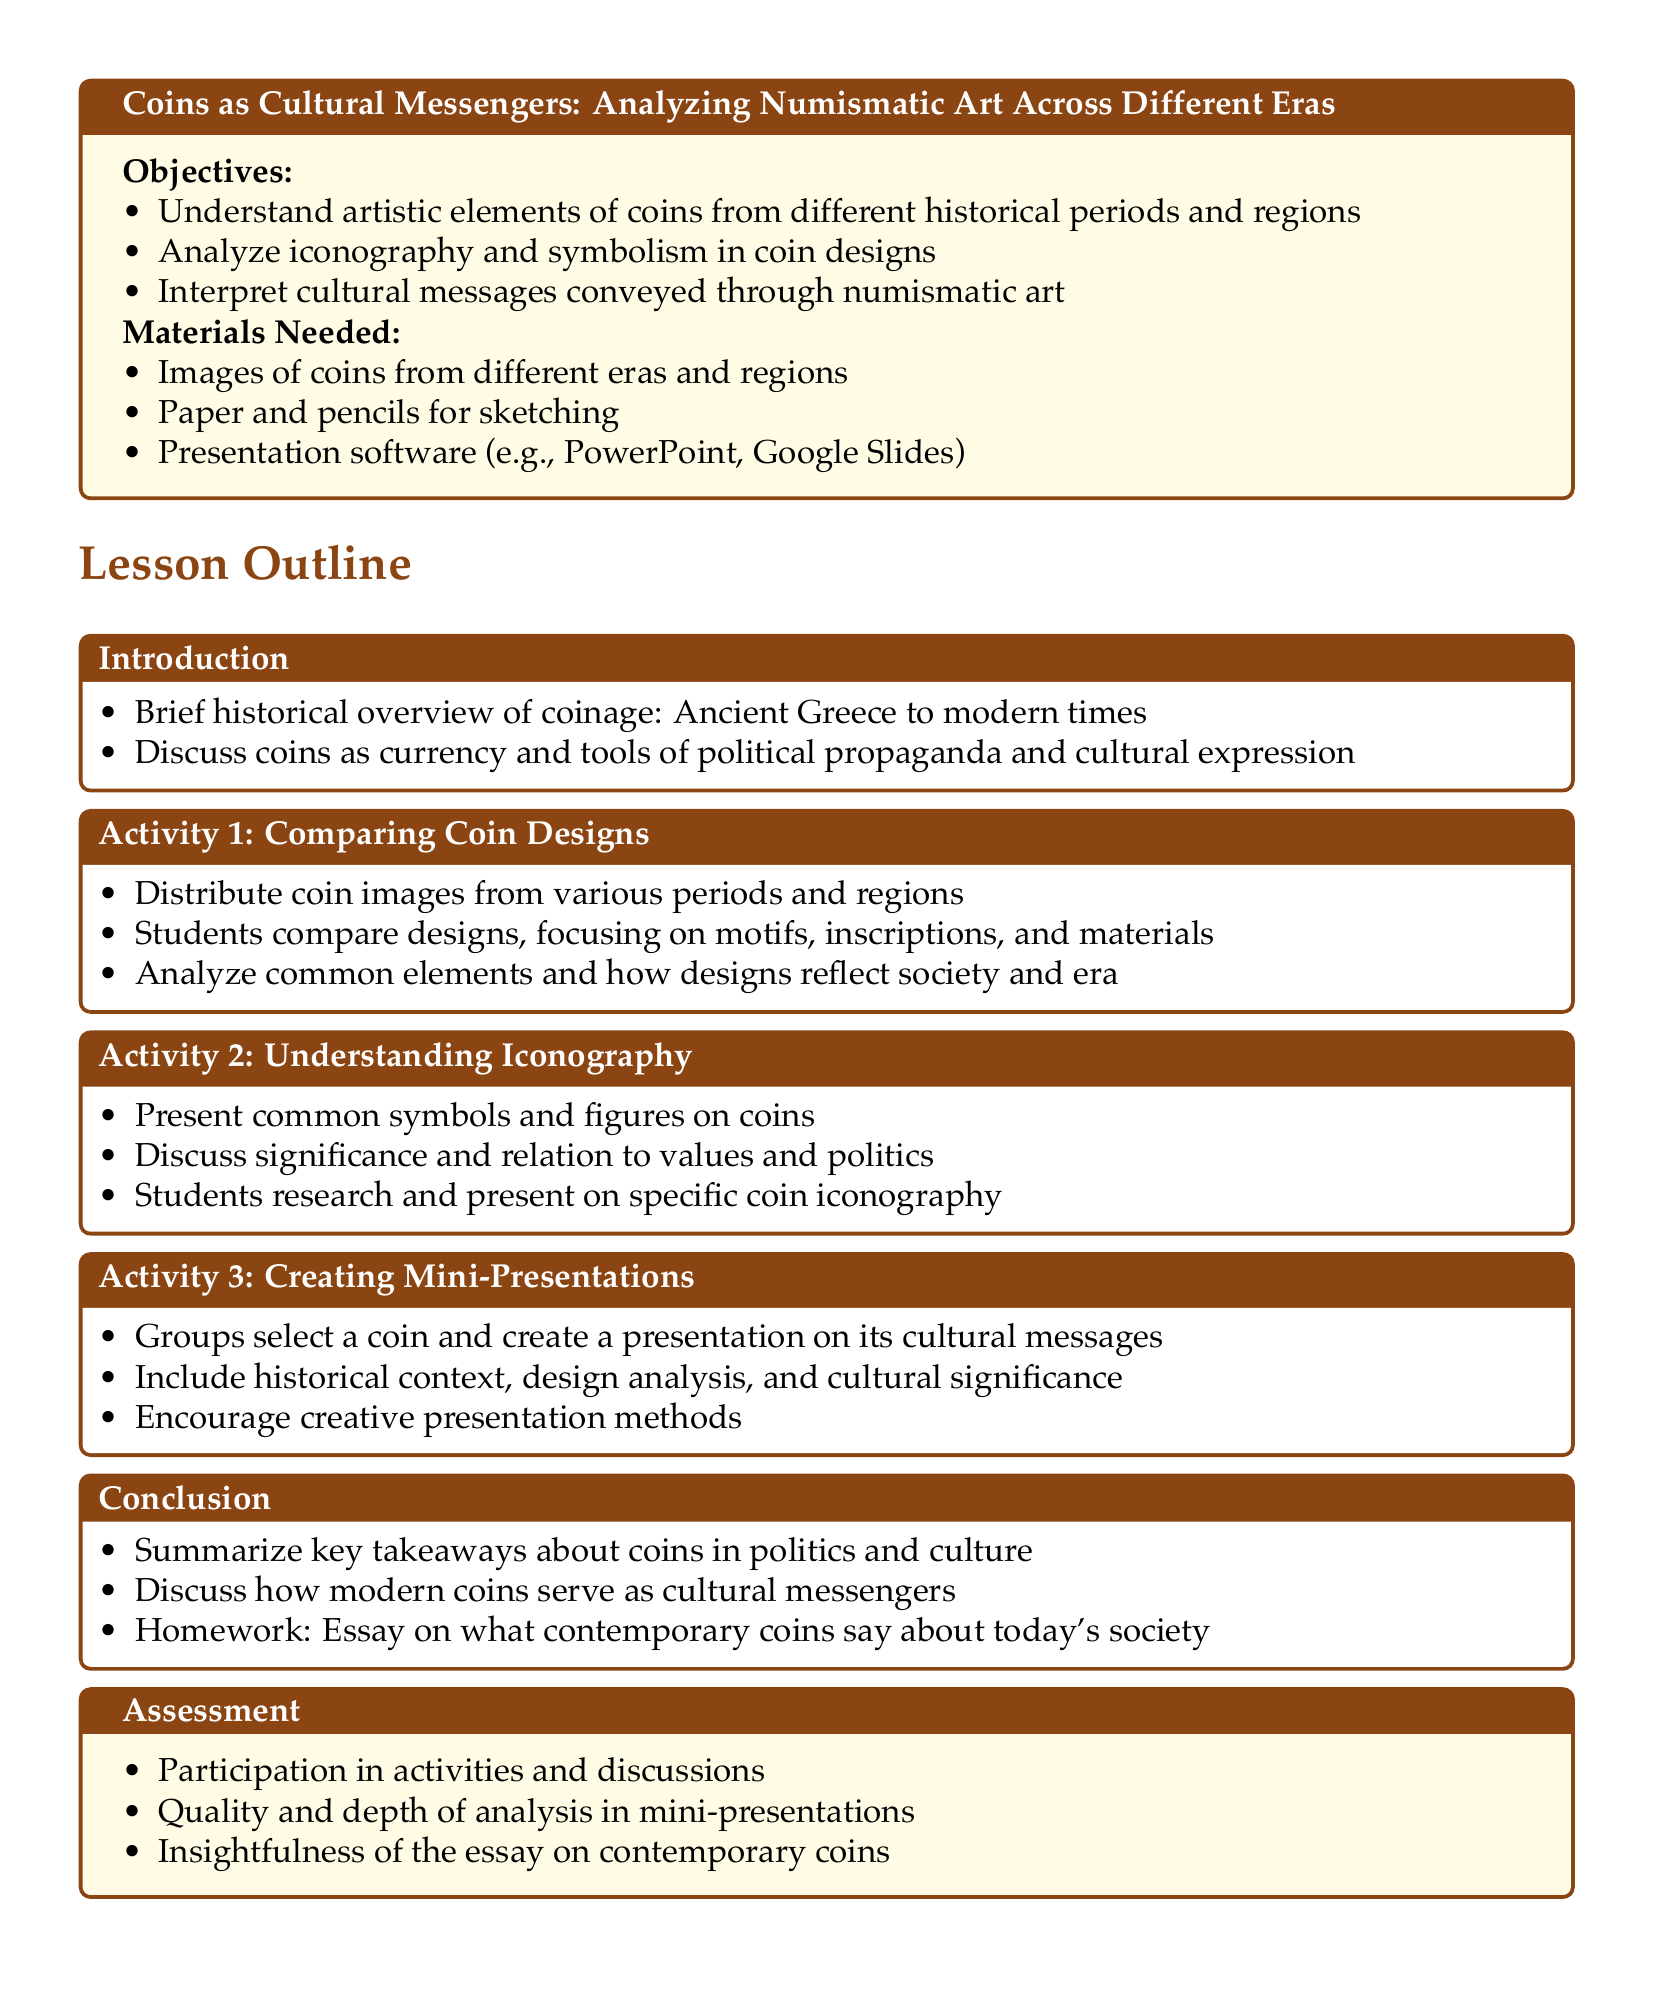What is the title of the lesson plan? The title appears at the top of the document and describes the main subject of the lesson, which deals with coins as cultural messengers.
Answer: Coins as Cultural Messengers: Analyzing Numismatic Art Across Different Eras What is one of the objectives of the lesson plan? Objectives are listed under "Objectives" in the document and highlight what students should understand or achieve.
Answer: Understand artistic elements of coins from different historical periods and regions What is one material needed for the activities? The materials needed are specified in a section of the document and include items necessary for the lesson activities.
Answer: Images of coins from different eras and regions What activity involves comparing designs? Each activity is named in the lesson plan, and this particular activity focuses on comparing coin designs.
Answer: Activity 1: Comparing Coin Designs What is the homework assignment described in the conclusion? The conclusion section summarizes key tasks for students and includes assignments related to the lesson content.
Answer: Essay on what contemporary coins say about today's society What is one type of assessment mentioned in the document? The assessment section describes how students will be evaluated, including different aspects of their participation and work.
Answer: Quality and depth of analysis in mini-presentations How many activities are outlined in the lesson plan? The lesson outline includes several activities that are numbered and titled.
Answer: Three What historical periods are referenced in the lesson overview? The overview gives a brief historical context for the lesson, highlighting the time span covered in the discussion.
Answer: Ancient Greece to modern times What does Activity 2 focus on? Activity titles indicate their focus, and this one specifically addresses the analysis of symbols found on coins.
Answer: Understanding Iconography 